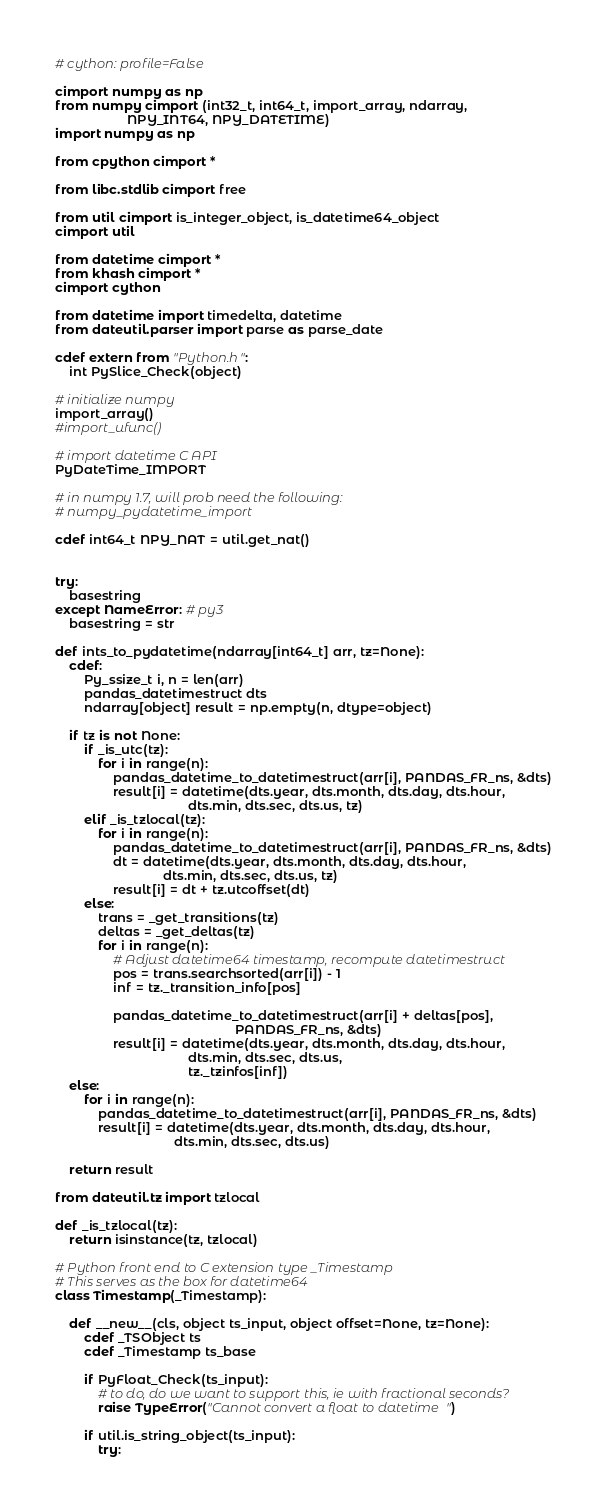<code> <loc_0><loc_0><loc_500><loc_500><_Cython_># cython: profile=False

cimport numpy as np
from numpy cimport (int32_t, int64_t, import_array, ndarray,
                    NPY_INT64, NPY_DATETIME)
import numpy as np

from cpython cimport *

from libc.stdlib cimport free

from util cimport is_integer_object, is_datetime64_object
cimport util

from datetime cimport *
from khash cimport *
cimport cython

from datetime import timedelta, datetime
from dateutil.parser import parse as parse_date

cdef extern from "Python.h":
    int PySlice_Check(object)

# initialize numpy
import_array()
#import_ufunc()

# import datetime C API
PyDateTime_IMPORT

# in numpy 1.7, will prob need the following:
# numpy_pydatetime_import

cdef int64_t NPY_NAT = util.get_nat()


try:
    basestring
except NameError: # py3
    basestring = str

def ints_to_pydatetime(ndarray[int64_t] arr, tz=None):
    cdef:
        Py_ssize_t i, n = len(arr)
        pandas_datetimestruct dts
        ndarray[object] result = np.empty(n, dtype=object)

    if tz is not None:
        if _is_utc(tz):
            for i in range(n):
                pandas_datetime_to_datetimestruct(arr[i], PANDAS_FR_ns, &dts)
                result[i] = datetime(dts.year, dts.month, dts.day, dts.hour,
                                     dts.min, dts.sec, dts.us, tz)
        elif _is_tzlocal(tz):
            for i in range(n):
                pandas_datetime_to_datetimestruct(arr[i], PANDAS_FR_ns, &dts)
                dt = datetime(dts.year, dts.month, dts.day, dts.hour,
                              dts.min, dts.sec, dts.us, tz)
                result[i] = dt + tz.utcoffset(dt)
        else:
            trans = _get_transitions(tz)
            deltas = _get_deltas(tz)
            for i in range(n):
                # Adjust datetime64 timestamp, recompute datetimestruct
                pos = trans.searchsorted(arr[i]) - 1
                inf = tz._transition_info[pos]

                pandas_datetime_to_datetimestruct(arr[i] + deltas[pos],
                                                  PANDAS_FR_ns, &dts)
                result[i] = datetime(dts.year, dts.month, dts.day, dts.hour,
                                     dts.min, dts.sec, dts.us,
                                     tz._tzinfos[inf])
    else:
        for i in range(n):
            pandas_datetime_to_datetimestruct(arr[i], PANDAS_FR_ns, &dts)
            result[i] = datetime(dts.year, dts.month, dts.day, dts.hour,
                                 dts.min, dts.sec, dts.us)

    return result

from dateutil.tz import tzlocal

def _is_tzlocal(tz):
    return isinstance(tz, tzlocal)

# Python front end to C extension type _Timestamp
# This serves as the box for datetime64
class Timestamp(_Timestamp):

    def __new__(cls, object ts_input, object offset=None, tz=None):
        cdef _TSObject ts
        cdef _Timestamp ts_base

        if PyFloat_Check(ts_input):
            # to do, do we want to support this, ie with fractional seconds?
            raise TypeError("Cannot convert a float to datetime")

        if util.is_string_object(ts_input):
            try:</code> 